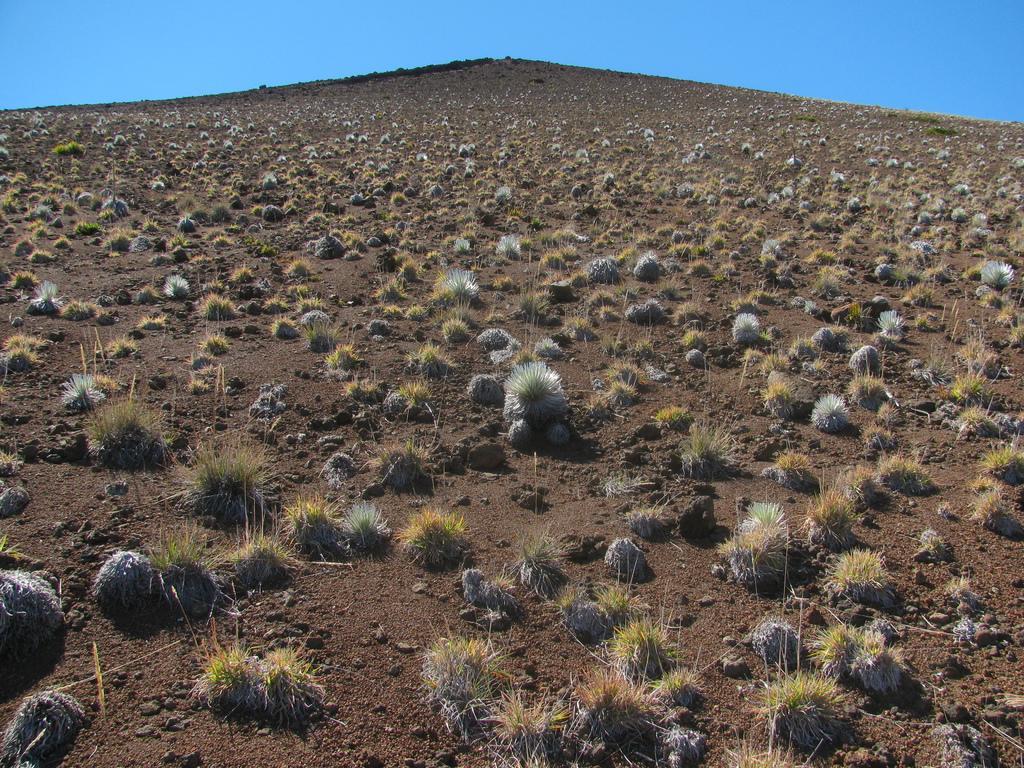Can you describe this image briefly? In this image we can see plants. In the background there is sky. 